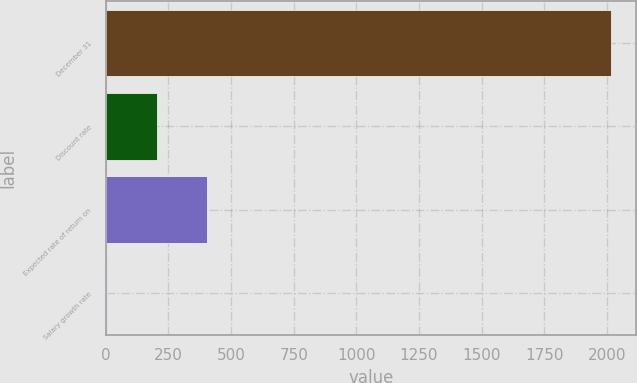Convert chart to OTSL. <chart><loc_0><loc_0><loc_500><loc_500><bar_chart><fcel>December 31<fcel>Discount rate<fcel>Expected rate of return on<fcel>Salary growth rate<nl><fcel>2014<fcel>204.19<fcel>405.28<fcel>3.1<nl></chart> 